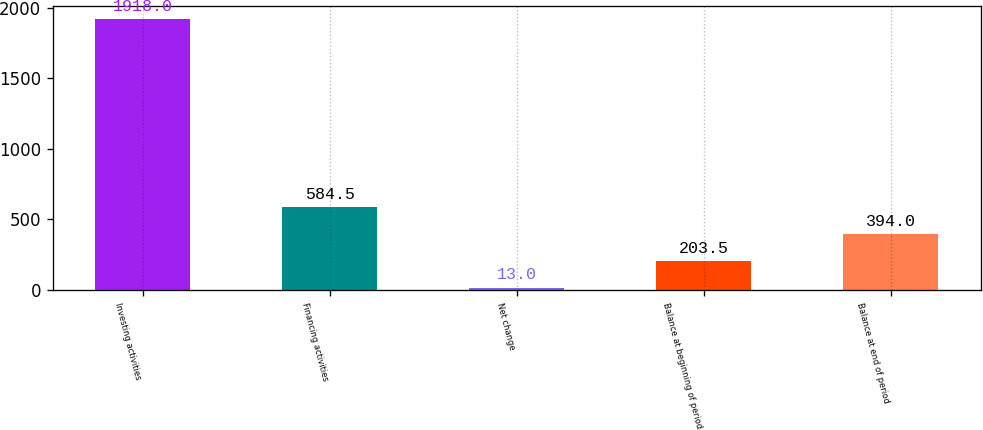Convert chart. <chart><loc_0><loc_0><loc_500><loc_500><bar_chart><fcel>Investing activities<fcel>Financing activities<fcel>Net change<fcel>Balance at beginning of period<fcel>Balance at end of period<nl><fcel>1918<fcel>584.5<fcel>13<fcel>203.5<fcel>394<nl></chart> 